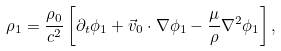<formula> <loc_0><loc_0><loc_500><loc_500>\rho _ { 1 } = \frac { \rho _ { 0 } } { c ^ { 2 } } \left [ \partial _ { t } \phi _ { 1 } + \vec { v } _ { 0 } \cdot \nabla \phi _ { 1 } - \frac { \mu } { \rho } \nabla ^ { 2 } \phi _ { 1 } \right ] ,</formula> 